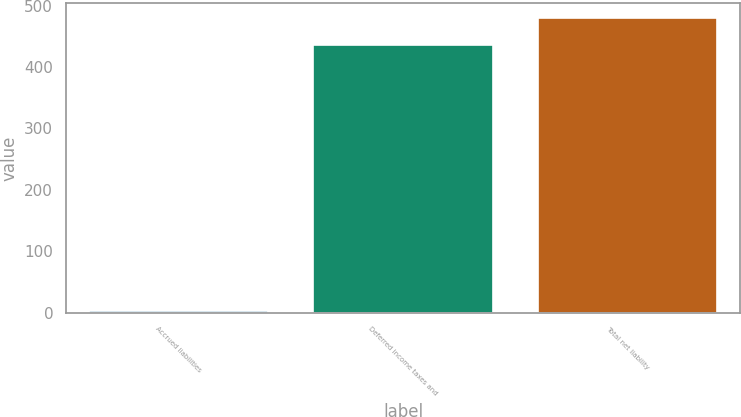Convert chart to OTSL. <chart><loc_0><loc_0><loc_500><loc_500><bar_chart><fcel>Accrued liabilities<fcel>Deferred income taxes and<fcel>Total net liability<nl><fcel>3<fcel>436<fcel>479.6<nl></chart> 